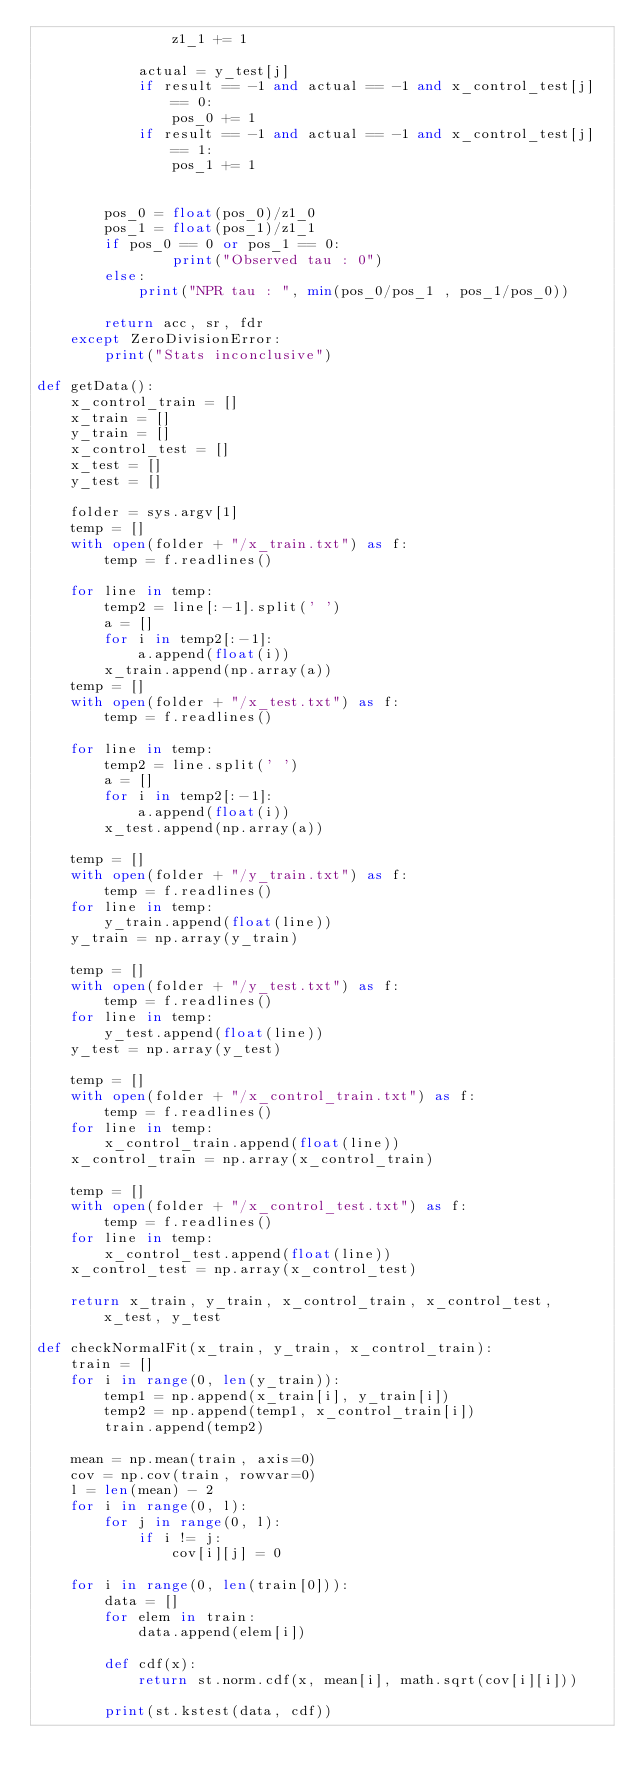Convert code to text. <code><loc_0><loc_0><loc_500><loc_500><_Python_>				z1_1 += 1

			actual = y_test[j]
			if result == -1 and actual == -1 and x_control_test[j] == 0:
				pos_0 += 1
			if result == -1 and actual == -1 and x_control_test[j] == 1:
				pos_1 += 1


		pos_0 = float(pos_0)/z1_0
		pos_1 = float(pos_1)/z1_1
		if pos_0 == 0 or pos_1 == 0:
				print("Observed tau : 0")
		else:
			print("NPR tau : ", min(pos_0/pos_1 , pos_1/pos_0))

		return acc, sr, fdr
	except ZeroDivisionError:
		print("Stats inconclusive")

def getData():
	x_control_train = []
	x_train = []
	y_train = []
	x_control_test = []
	x_test = []
	y_test = []

	folder = sys.argv[1]
	temp = []
	with open(folder + "/x_train.txt") as f:
		temp = f.readlines()

	for line in temp:
		temp2 = line[:-1].split(' ')
		a = []
		for i in temp2[:-1]:
			a.append(float(i))
		x_train.append(np.array(a))
	temp = []
	with open(folder + "/x_test.txt") as f:
		temp = f.readlines()

	for line in temp:
		temp2 = line.split(' ')
		a = []
		for i in temp2[:-1]:
			a.append(float(i))
		x_test.append(np.array(a))

	temp = []
	with open(folder + "/y_train.txt") as f:
		temp = f.readlines()
	for line in temp:
		y_train.append(float(line))
	y_train = np.array(y_train)

	temp = []
	with open(folder + "/y_test.txt") as f:
		temp = f.readlines()
	for line in temp:
		y_test.append(float(line))
	y_test = np.array(y_test)

	temp = []
	with open(folder + "/x_control_train.txt") as f:
		temp = f.readlines()
	for line in temp:
		x_control_train.append(float(line))
	x_control_train = np.array(x_control_train)

	temp = []
	with open(folder + "/x_control_test.txt") as f:
		temp = f.readlines()
	for line in temp:
		x_control_test.append(float(line))
	x_control_test = np.array(x_control_test)

	return x_train, y_train, x_control_train, x_control_test, x_test, y_test

def checkNormalFit(x_train, y_train, x_control_train):
	train = []
	for i in range(0, len(y_train)):
		temp1 = np.append(x_train[i], y_train[i])
		temp2 = np.append(temp1, x_control_train[i])
		train.append(temp2)

	mean = np.mean(train, axis=0)
	cov = np.cov(train, rowvar=0)
	l = len(mean) - 2
	for i in range(0, l):
		for j in range(0, l):
			if i != j:
				cov[i][j] = 0

	for i in range(0, len(train[0])):
		data = []
		for elem in train:
			data.append(elem[i])

		def cdf(x):
			return st.norm.cdf(x, mean[i], math.sqrt(cov[i][i]))

		print(st.kstest(data, cdf))
</code> 